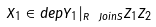<formula> <loc_0><loc_0><loc_500><loc_500>X _ { 1 } \in d e p Y _ { 1 } | _ { R \ J o i n S } Z _ { 1 } Z _ { 2 }</formula> 